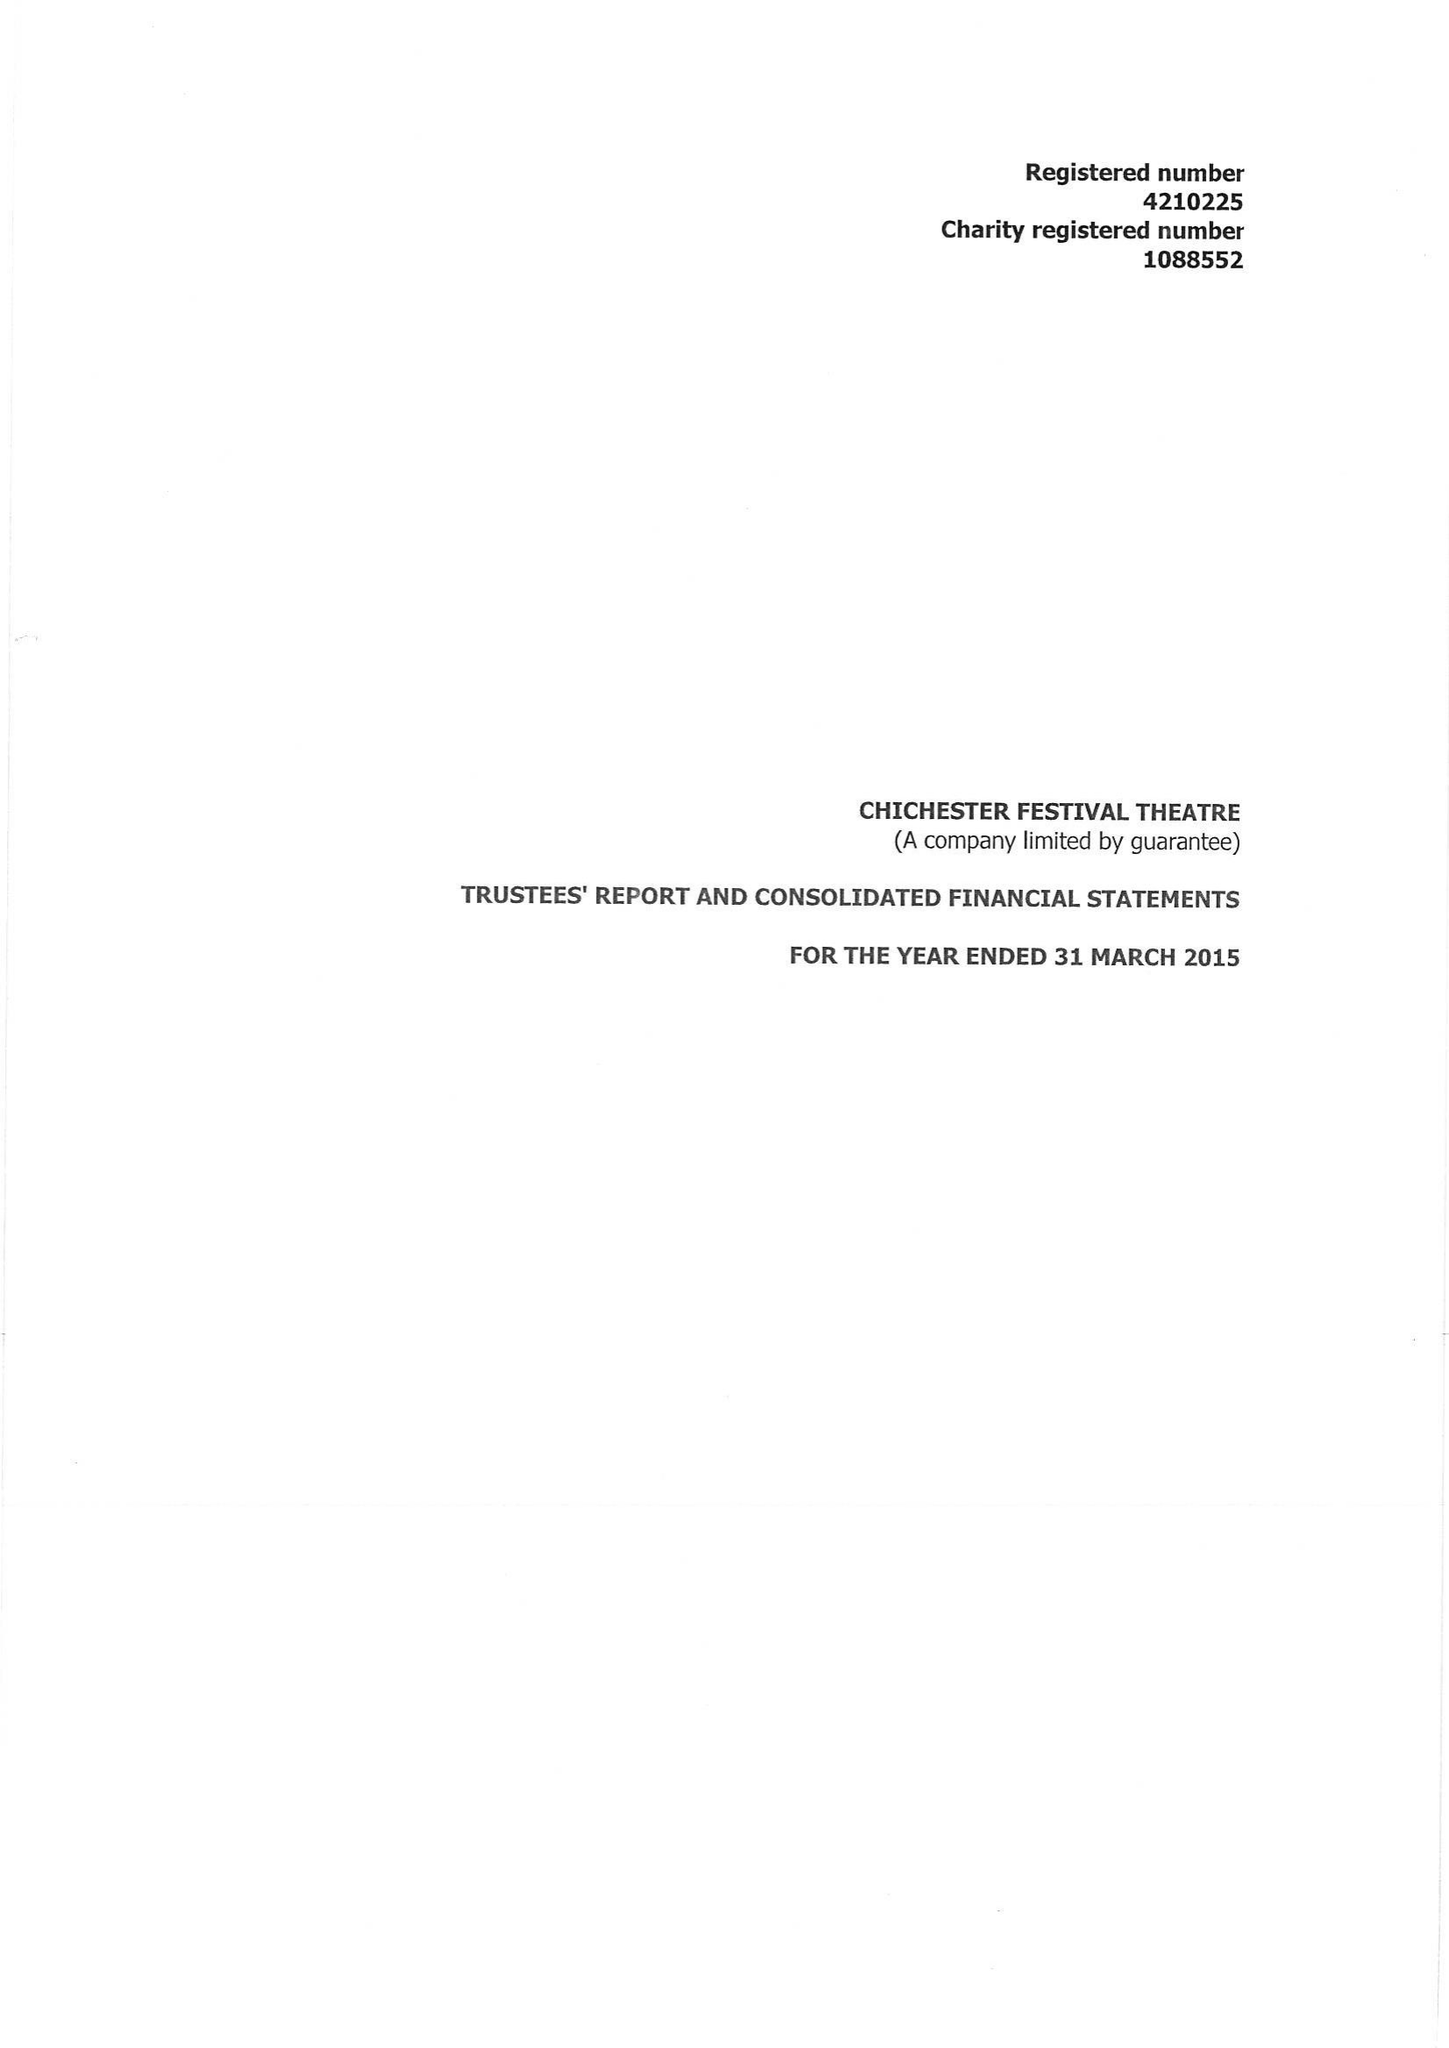What is the value for the report_date?
Answer the question using a single word or phrase. 2015-03-31 